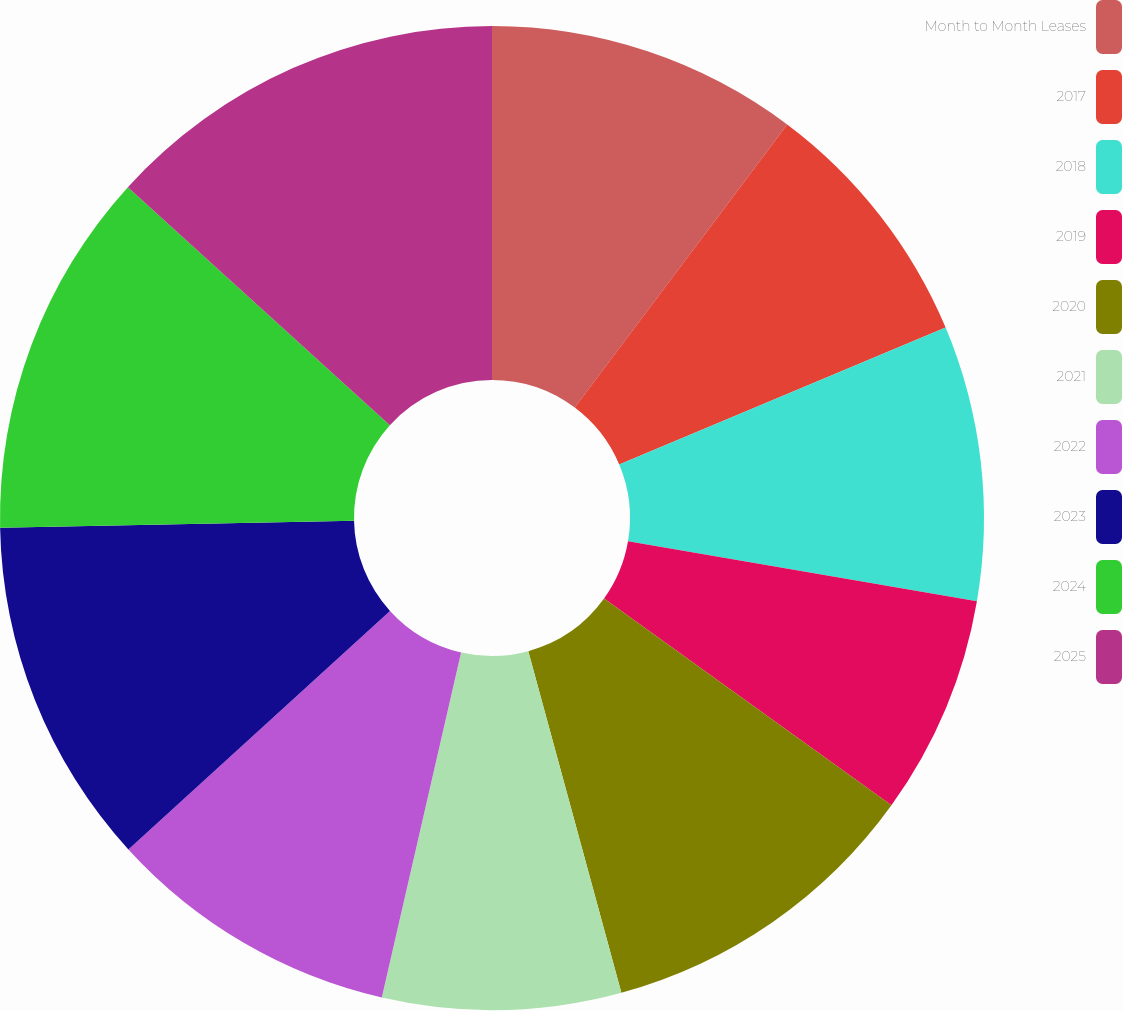Convert chart to OTSL. <chart><loc_0><loc_0><loc_500><loc_500><pie_chart><fcel>Month to Month Leases<fcel>2017<fcel>2018<fcel>2019<fcel>2020<fcel>2021<fcel>2022<fcel>2023<fcel>2024<fcel>2025<nl><fcel>10.24%<fcel>8.43%<fcel>9.03%<fcel>7.22%<fcel>10.84%<fcel>7.83%<fcel>9.64%<fcel>11.45%<fcel>12.05%<fcel>13.26%<nl></chart> 